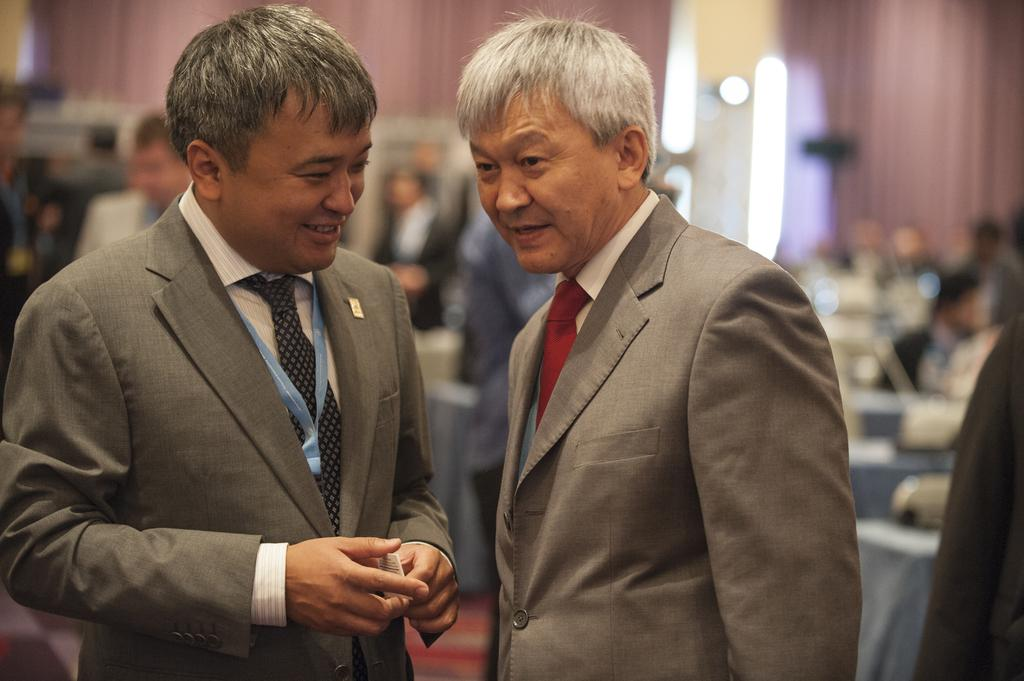How many individuals are present in the image? There are many people in the image. Can you describe the man's action on the left side of the image? A man is holding an object in his hand at the left side of the image. What type of furniture is visible in the image? There are many tables in the image. How many cherries are on the tables in the image? There is no mention of cherries in the image, so it is not possible to determine the number of cherries. 